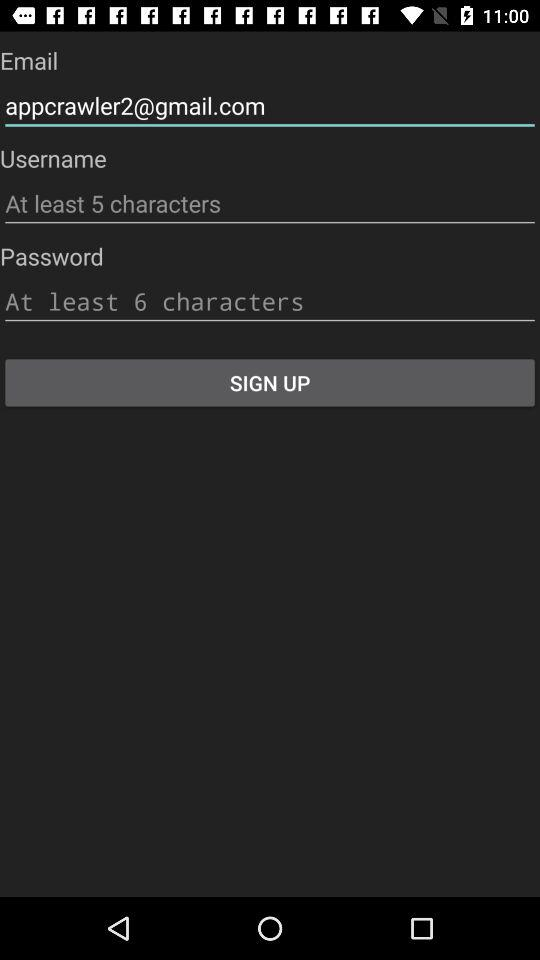How many text inputs are required to sign up?
Answer the question using a single word or phrase. 3 